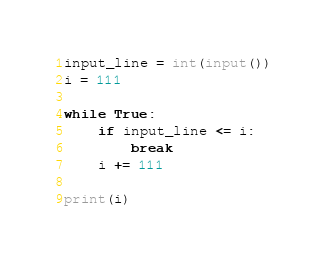<code> <loc_0><loc_0><loc_500><loc_500><_Python_>input_line = int(input())
i = 111

while True:
    if input_line <= i:
        break
    i += 111

print(i)</code> 